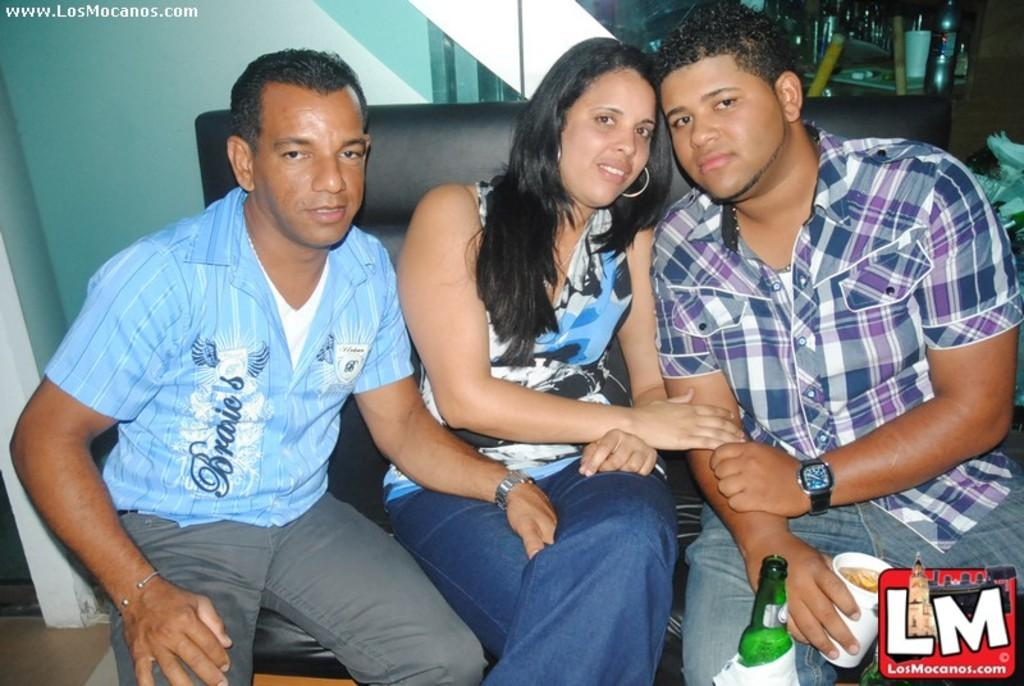Provide a one-sentence caption for the provided image. A photo of a woman seated between two men with a LosMocanos watermark. 